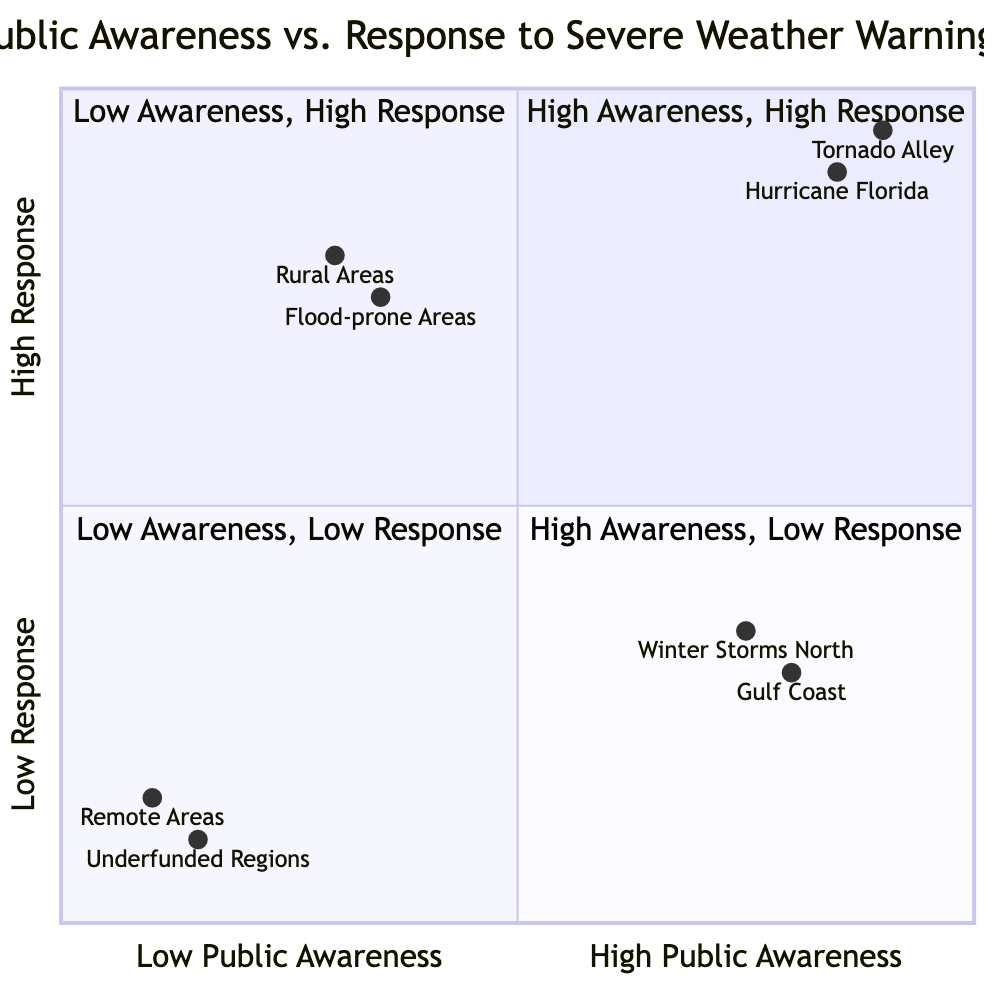What are the real-world examples in the high public awareness and high response quadrant? In the quadrant labeled "High Public Awareness - High Response," the diagram lists "Tornado Alley awareness in Oklahoma and Kansas" and "Hurricane preparedness in Florida" as factual instances, which relate to these attributes.
Answer: Tornado Alley awareness in Oklahoma and Kansas, Hurricane preparedness in Florida Which quadrant has the highest compliance with issued warnings? The quadrant labeled "High Public Awareness - High Response" indicates that this area experiences "High compliance with issued warnings," illustrating a strong link between awareness and response.
Answer: High Public Awareness - High Response What is the public awareness level associated with complacency? The quadrant titled "High Public Awareness - Low Response" contains the term "Complacency despite the knowledge." This indicates that high awareness can exist without corresponding action.
Answer: High Public Awareness - Low Response Which location has the highest public awareness score? The diagram shows that "Tornado Alley" is represented at coordinates [0.9, 0.95], meaning it has a high score in both public awareness and response, suggesting high engagement in this region.
Answer: Tornado Alley How do rural areas respond to severe weather warnings, despite low public awareness? The data for the "Low Public Awareness - High Response" quadrant indicates that rural areas maintain a "Strong community network to spread warnings," despite limited awareness initiatives.
Answer: Strong community network to spread warnings What is a reason for low preparedness in public awareness and low response quadrant? In the "Low Public Awareness - Low Response" quadrant, the description includes "Public skepticism towards warnings" which provides insight into why preparedness is lacking in this context.
Answer: Public skepticism towards warnings What is the evacuation rate status in high public awareness and high response areas? The high public awareness and high response quadrant specifies "High evacuation rates," reflecting the effectiveness of outreach in prompting action during severe weather events.
Answer: High evacuation rates Which quadrant sees effective local emergency response teams? The "Low Public Awareness - High Response" quadrant highlights "Effective local emergency response teams" as a significant feature, showcasing the community's ability to react well despite limited awareness.
Answer: Low Public Awareness - High Response What type of community programs are present in low public awareness areas with high response? The "Low Public Awareness - High Response" quadrant includes "Reliable family or community action plans," indicating that preparedness measures exist even when public awareness is limited.
Answer: Reliable family or community action plans 